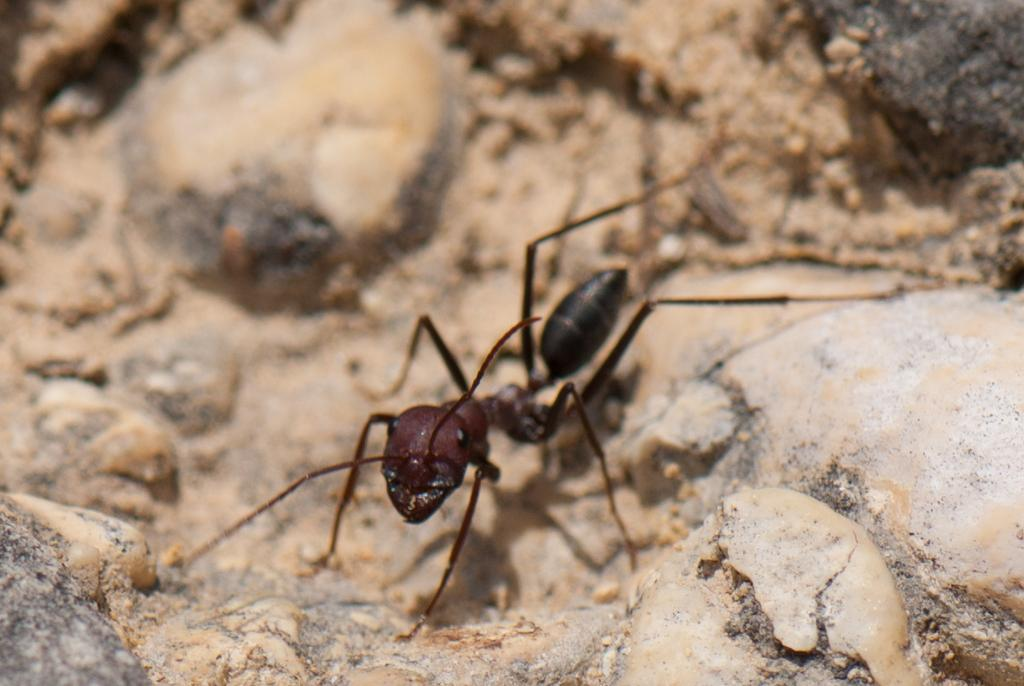What type of creature is present in the image? There is an ant in the image. What colors can be seen on the ant? The ant is brown and black in color. On what surface is the ant located? The ant is on a rocky surface. What is the color of the rocky surface? The rocky surface is brown in color. What type of son can be heard coming from the ant in the image? There is no indication in the image that the ant is making any sounds, so it's not possible to determine what type of son might be heard. 